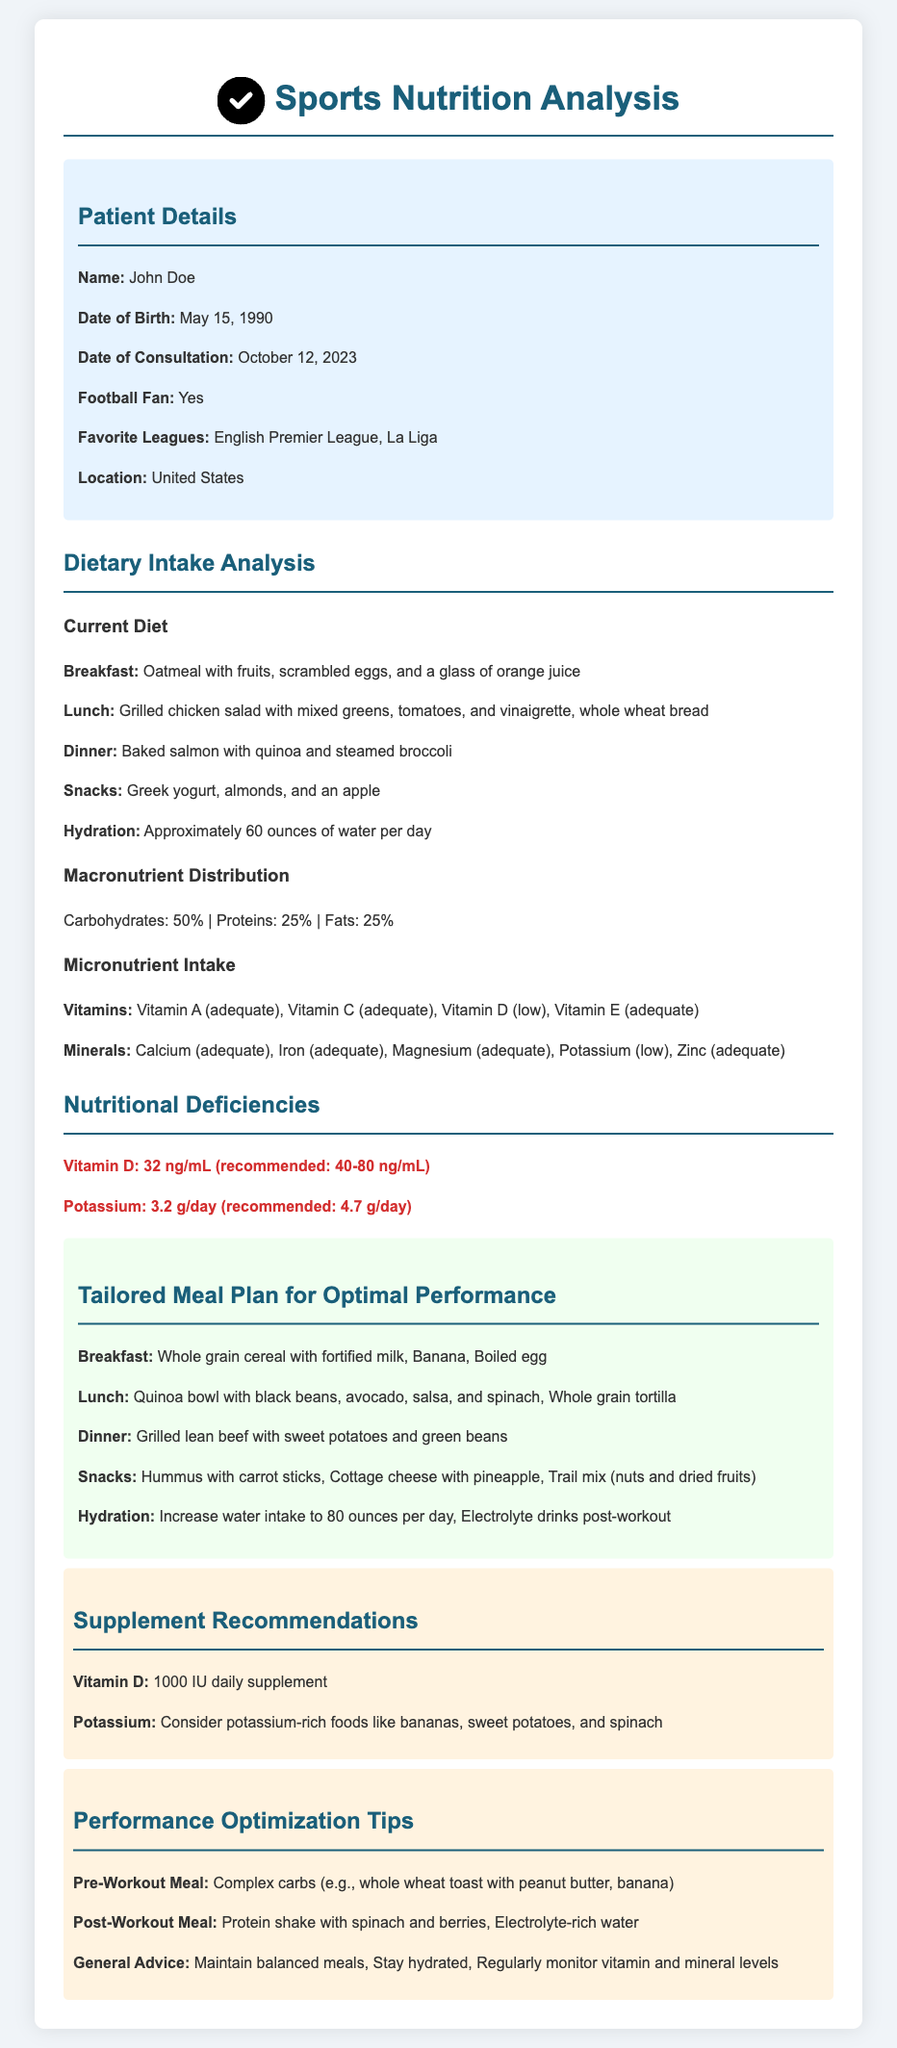What is the patient's name? The patient's name is mentioned in the Patient Details section.
Answer: John Doe When was the consultation date? The consultation date is specified in the Patient Details section.
Answer: October 12, 2023 What is the recommended daily intake of Vitamin D? The document states the recommended level for Vitamin D in the Nutritional Deficiencies section.
Answer: 40-80 ng/mL What is the patient's hydration level? The hydration level is detailed in the Dietary Intake Analysis section.
Answer: Approximately 60 ounces of water per day What is the tailored breakfast in the meal plan? The tailored breakfast is highlighted in the Tailored Meal Plan section.
Answer: Whole grain cereal with fortified milk, Banana, Boiled egg How many grams of potassium does the patient currently consume daily? The patient's potassium intake is provided in the Nutritional Deficiencies section.
Answer: 3.2 g/day What is one supplement recommended for the patient? The recommended supplement is listed in the Supplement Recommendations section.
Answer: 1000 IU daily supplement What type of meal is suggested for post-workout? The post-workout meal suggestion is mentioned in the Performance Optimization Tips section.
Answer: Protein shake with spinach and berries What percentage of the patient's diet consists of carbohydrates? The macronutrient distribution is detailed in the Dietary Intake Analysis section.
Answer: 50% 